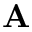<formula> <loc_0><loc_0><loc_500><loc_500>A</formula> 